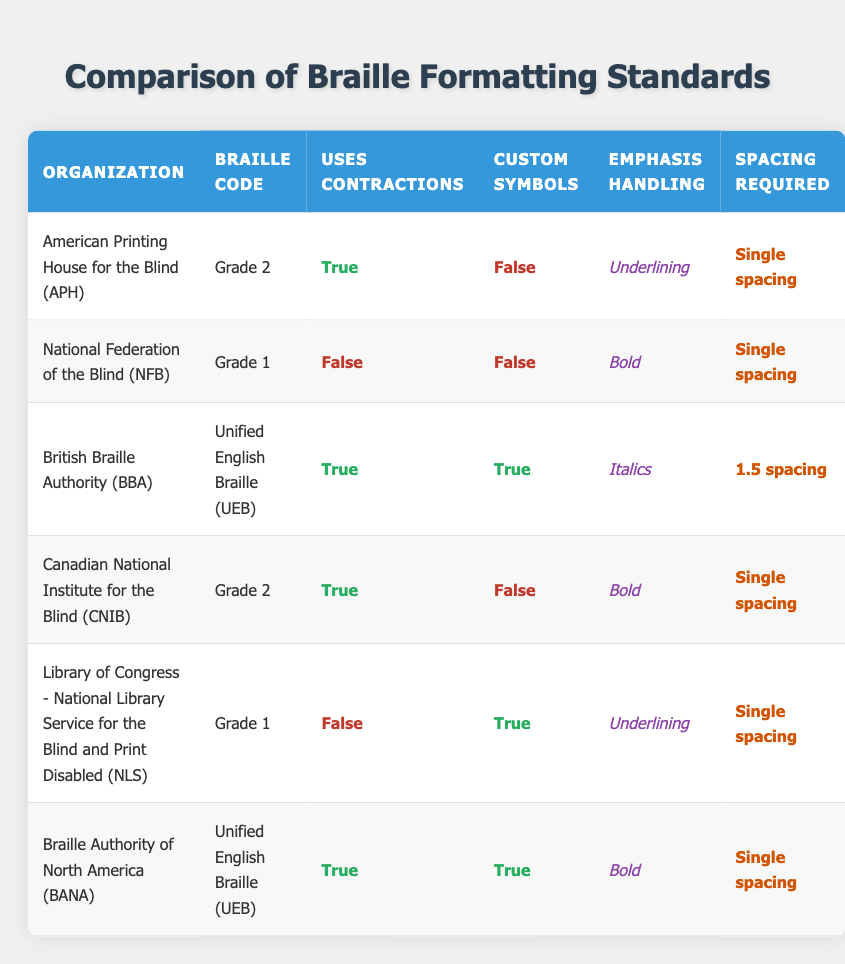What braille code does the National Federation of the Blind use? The table shows each organization's corresponding braille code. For the National Federation of the Blind, listed in the second row, the braille code is Grade 1.
Answer: Grade 1 Which organizations use Unified English Braille? The table identifies the organizations and their respective braille codes. Unified English Braille is used by the British Braille Authority and the Braille Authority of North America, as evidenced in rows 3 and 6.
Answer: British Braille Authority, Braille Authority of North America Do any organizations use contractions in their braille code? The table contains a column indicating whether each organization uses contractions. The organizations that use contractions are the American Printing House for the Blind, British Braille Authority, Canadian National Institute for the Blind, and Braille Authority of North America.
Answer: Yes What is the spacing required by the British Braille Authority? The table allows retrieval of the spacing information specifically for the British Braille Authority. The relevant row indicates that the spacing required is 1.5 spacing.
Answer: 1.5 spacing How many organizations use custom symbols? To answer this question, we need to analyze the table and count the organizations that have "True" in the custom symbols column. The organizations with custom symbols are British Braille Authority and Library of Congress - National Library Service for the Blind and Print Disabled, totaling two organizations.
Answer: 2 Which organization has the most distinctive emphasis handling? By looking at the emphasis handling column in the table, we see that it varies by organization. The British Braille Authority employs italics, while others use underlining or bold. Therefore, the emphasis handling for British Braille Authority stands out as uniquely different.
Answer: British Braille Authority Is there any organization that offers Grade 1 braille code with contractions? The table specifies that the National Federation of the Blind (Grade 1) and Library of Congress (Grade 1) do not use contractions. Therefore, no organizations providing Grade 1 braille code use contractions.
Answer: No What is the spacing required by organizations using Grade 2 braille code? The two organizations listed using Grade 2 braille code are American Printing House for the Blind and Canadian National Institute for the Blind. Both organizations require single spacing according to the spacing required column.
Answer: Single spacing 